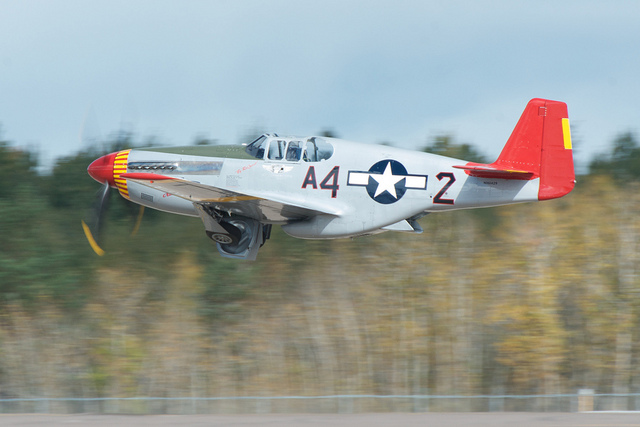Is this a jet aircraft?
Answer the question using a single word or phrase. No Is there a star in the scene? Yes Is this a commercial airplane? No 